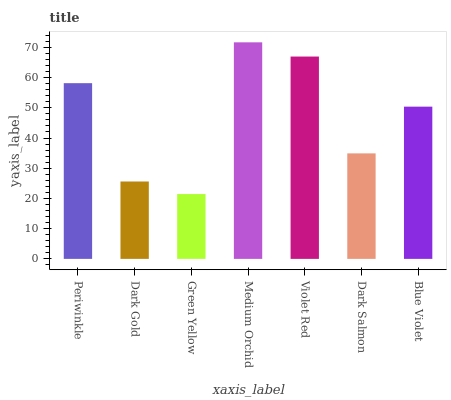Is Green Yellow the minimum?
Answer yes or no. Yes. Is Medium Orchid the maximum?
Answer yes or no. Yes. Is Dark Gold the minimum?
Answer yes or no. No. Is Dark Gold the maximum?
Answer yes or no. No. Is Periwinkle greater than Dark Gold?
Answer yes or no. Yes. Is Dark Gold less than Periwinkle?
Answer yes or no. Yes. Is Dark Gold greater than Periwinkle?
Answer yes or no. No. Is Periwinkle less than Dark Gold?
Answer yes or no. No. Is Blue Violet the high median?
Answer yes or no. Yes. Is Blue Violet the low median?
Answer yes or no. Yes. Is Dark Gold the high median?
Answer yes or no. No. Is Dark Gold the low median?
Answer yes or no. No. 